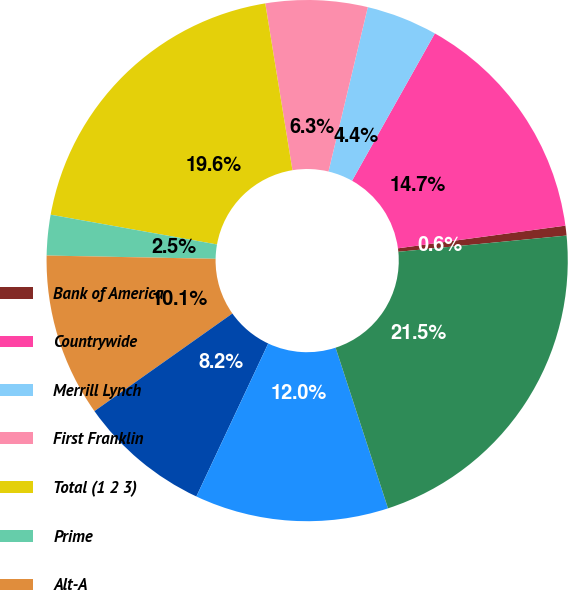Convert chart to OTSL. <chart><loc_0><loc_0><loc_500><loc_500><pie_chart><fcel>Bank of America<fcel>Countrywide<fcel>Merrill Lynch<fcel>First Franklin<fcel>Total (1 2 3)<fcel>Prime<fcel>Alt-A<fcel>Pay option<fcel>Subprime<fcel>Total<nl><fcel>0.61%<fcel>14.71%<fcel>4.41%<fcel>6.31%<fcel>19.61%<fcel>2.51%<fcel>10.11%<fcel>8.21%<fcel>12.01%<fcel>21.51%<nl></chart> 